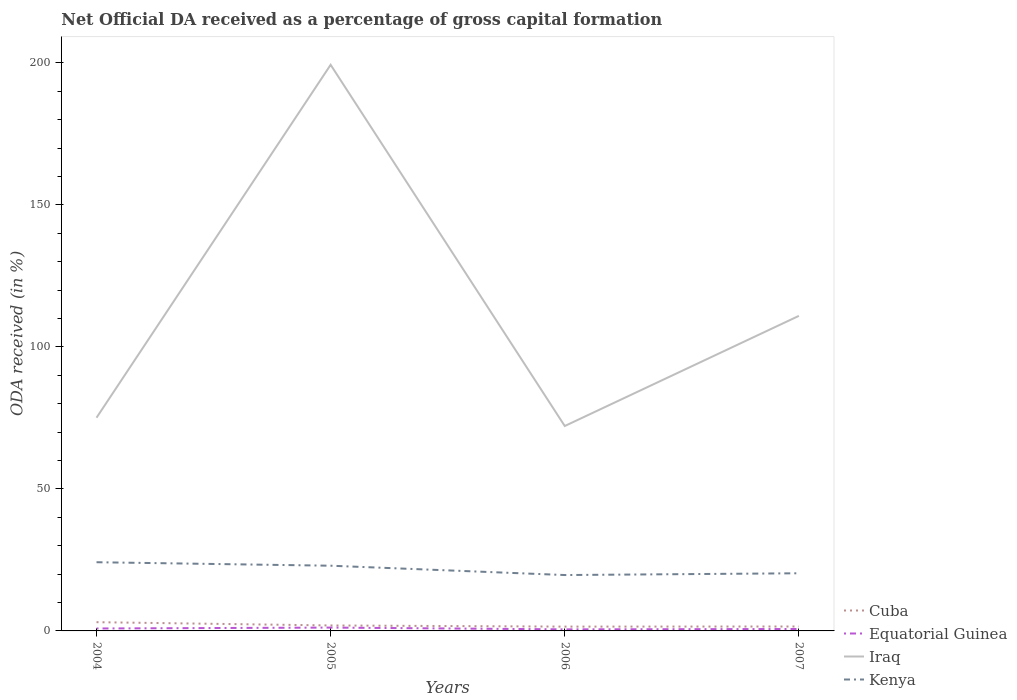How many different coloured lines are there?
Keep it short and to the point. 4. Does the line corresponding to Cuba intersect with the line corresponding to Equatorial Guinea?
Your response must be concise. No. Across all years, what is the maximum net ODA received in Cuba?
Make the answer very short. 1.51. What is the total net ODA received in Kenya in the graph?
Give a very brief answer. 3.28. What is the difference between the highest and the second highest net ODA received in Iraq?
Your answer should be very brief. 127.16. What is the difference between the highest and the lowest net ODA received in Cuba?
Provide a short and direct response. 1. Is the net ODA received in Kenya strictly greater than the net ODA received in Cuba over the years?
Offer a very short reply. No. What is the difference between two consecutive major ticks on the Y-axis?
Your response must be concise. 50. Are the values on the major ticks of Y-axis written in scientific E-notation?
Give a very brief answer. No. Does the graph contain any zero values?
Your response must be concise. No. Does the graph contain grids?
Your answer should be very brief. No. How many legend labels are there?
Provide a short and direct response. 4. How are the legend labels stacked?
Your answer should be very brief. Vertical. What is the title of the graph?
Provide a short and direct response. Net Official DA received as a percentage of gross capital formation. Does "Paraguay" appear as one of the legend labels in the graph?
Keep it short and to the point. No. What is the label or title of the Y-axis?
Offer a very short reply. ODA received (in %). What is the ODA received (in %) of Cuba in 2004?
Your response must be concise. 3.08. What is the ODA received (in %) of Equatorial Guinea in 2004?
Your answer should be compact. 0.86. What is the ODA received (in %) of Iraq in 2004?
Provide a succinct answer. 75.06. What is the ODA received (in %) of Kenya in 2004?
Provide a succinct answer. 24.18. What is the ODA received (in %) in Cuba in 2005?
Offer a very short reply. 1.92. What is the ODA received (in %) in Equatorial Guinea in 2005?
Your answer should be very brief. 1.18. What is the ODA received (in %) of Iraq in 2005?
Your answer should be very brief. 199.29. What is the ODA received (in %) of Kenya in 2005?
Provide a succinct answer. 22.96. What is the ODA received (in %) in Cuba in 2006?
Offer a very short reply. 1.51. What is the ODA received (in %) in Equatorial Guinea in 2006?
Provide a succinct answer. 0.55. What is the ODA received (in %) in Iraq in 2006?
Your answer should be compact. 72.14. What is the ODA received (in %) in Kenya in 2006?
Your answer should be very brief. 19.67. What is the ODA received (in %) of Cuba in 2007?
Keep it short and to the point. 1.55. What is the ODA received (in %) of Equatorial Guinea in 2007?
Keep it short and to the point. 0.68. What is the ODA received (in %) in Iraq in 2007?
Offer a very short reply. 110.91. What is the ODA received (in %) in Kenya in 2007?
Offer a terse response. 20.29. Across all years, what is the maximum ODA received (in %) of Cuba?
Your answer should be compact. 3.08. Across all years, what is the maximum ODA received (in %) in Equatorial Guinea?
Make the answer very short. 1.18. Across all years, what is the maximum ODA received (in %) of Iraq?
Your answer should be compact. 199.29. Across all years, what is the maximum ODA received (in %) in Kenya?
Make the answer very short. 24.18. Across all years, what is the minimum ODA received (in %) in Cuba?
Offer a very short reply. 1.51. Across all years, what is the minimum ODA received (in %) of Equatorial Guinea?
Provide a succinct answer. 0.55. Across all years, what is the minimum ODA received (in %) of Iraq?
Your answer should be very brief. 72.14. Across all years, what is the minimum ODA received (in %) of Kenya?
Provide a succinct answer. 19.67. What is the total ODA received (in %) of Cuba in the graph?
Your answer should be compact. 8.07. What is the total ODA received (in %) in Equatorial Guinea in the graph?
Provide a short and direct response. 3.26. What is the total ODA received (in %) of Iraq in the graph?
Keep it short and to the point. 457.39. What is the total ODA received (in %) of Kenya in the graph?
Your answer should be compact. 87.11. What is the difference between the ODA received (in %) of Cuba in 2004 and that in 2005?
Keep it short and to the point. 1.16. What is the difference between the ODA received (in %) in Equatorial Guinea in 2004 and that in 2005?
Offer a terse response. -0.32. What is the difference between the ODA received (in %) of Iraq in 2004 and that in 2005?
Give a very brief answer. -124.24. What is the difference between the ODA received (in %) of Kenya in 2004 and that in 2005?
Provide a succinct answer. 1.23. What is the difference between the ODA received (in %) in Cuba in 2004 and that in 2006?
Ensure brevity in your answer.  1.56. What is the difference between the ODA received (in %) of Equatorial Guinea in 2004 and that in 2006?
Give a very brief answer. 0.31. What is the difference between the ODA received (in %) of Iraq in 2004 and that in 2006?
Offer a terse response. 2.92. What is the difference between the ODA received (in %) of Kenya in 2004 and that in 2006?
Ensure brevity in your answer.  4.51. What is the difference between the ODA received (in %) in Cuba in 2004 and that in 2007?
Make the answer very short. 1.52. What is the difference between the ODA received (in %) in Equatorial Guinea in 2004 and that in 2007?
Provide a short and direct response. 0.18. What is the difference between the ODA received (in %) in Iraq in 2004 and that in 2007?
Keep it short and to the point. -35.85. What is the difference between the ODA received (in %) in Kenya in 2004 and that in 2007?
Ensure brevity in your answer.  3.89. What is the difference between the ODA received (in %) of Cuba in 2005 and that in 2006?
Offer a terse response. 0.41. What is the difference between the ODA received (in %) in Equatorial Guinea in 2005 and that in 2006?
Provide a succinct answer. 0.62. What is the difference between the ODA received (in %) in Iraq in 2005 and that in 2006?
Make the answer very short. 127.16. What is the difference between the ODA received (in %) of Kenya in 2005 and that in 2006?
Keep it short and to the point. 3.28. What is the difference between the ODA received (in %) in Cuba in 2005 and that in 2007?
Your response must be concise. 0.37. What is the difference between the ODA received (in %) of Equatorial Guinea in 2005 and that in 2007?
Your response must be concise. 0.5. What is the difference between the ODA received (in %) in Iraq in 2005 and that in 2007?
Ensure brevity in your answer.  88.39. What is the difference between the ODA received (in %) of Kenya in 2005 and that in 2007?
Offer a terse response. 2.66. What is the difference between the ODA received (in %) in Cuba in 2006 and that in 2007?
Provide a succinct answer. -0.04. What is the difference between the ODA received (in %) in Equatorial Guinea in 2006 and that in 2007?
Make the answer very short. -0.13. What is the difference between the ODA received (in %) in Iraq in 2006 and that in 2007?
Give a very brief answer. -38.77. What is the difference between the ODA received (in %) in Kenya in 2006 and that in 2007?
Make the answer very short. -0.62. What is the difference between the ODA received (in %) of Cuba in 2004 and the ODA received (in %) of Equatorial Guinea in 2005?
Provide a succinct answer. 1.9. What is the difference between the ODA received (in %) of Cuba in 2004 and the ODA received (in %) of Iraq in 2005?
Ensure brevity in your answer.  -196.21. What is the difference between the ODA received (in %) of Cuba in 2004 and the ODA received (in %) of Kenya in 2005?
Your answer should be very brief. -19.88. What is the difference between the ODA received (in %) in Equatorial Guinea in 2004 and the ODA received (in %) in Iraq in 2005?
Give a very brief answer. -198.44. What is the difference between the ODA received (in %) in Equatorial Guinea in 2004 and the ODA received (in %) in Kenya in 2005?
Provide a succinct answer. -22.1. What is the difference between the ODA received (in %) of Iraq in 2004 and the ODA received (in %) of Kenya in 2005?
Your answer should be compact. 52.1. What is the difference between the ODA received (in %) in Cuba in 2004 and the ODA received (in %) in Equatorial Guinea in 2006?
Your response must be concise. 2.53. What is the difference between the ODA received (in %) in Cuba in 2004 and the ODA received (in %) in Iraq in 2006?
Your answer should be compact. -69.06. What is the difference between the ODA received (in %) in Cuba in 2004 and the ODA received (in %) in Kenya in 2006?
Ensure brevity in your answer.  -16.59. What is the difference between the ODA received (in %) in Equatorial Guinea in 2004 and the ODA received (in %) in Iraq in 2006?
Offer a terse response. -71.28. What is the difference between the ODA received (in %) of Equatorial Guinea in 2004 and the ODA received (in %) of Kenya in 2006?
Ensure brevity in your answer.  -18.81. What is the difference between the ODA received (in %) of Iraq in 2004 and the ODA received (in %) of Kenya in 2006?
Give a very brief answer. 55.38. What is the difference between the ODA received (in %) in Cuba in 2004 and the ODA received (in %) in Equatorial Guinea in 2007?
Provide a succinct answer. 2.4. What is the difference between the ODA received (in %) in Cuba in 2004 and the ODA received (in %) in Iraq in 2007?
Your answer should be compact. -107.83. What is the difference between the ODA received (in %) of Cuba in 2004 and the ODA received (in %) of Kenya in 2007?
Keep it short and to the point. -17.22. What is the difference between the ODA received (in %) of Equatorial Guinea in 2004 and the ODA received (in %) of Iraq in 2007?
Make the answer very short. -110.05. What is the difference between the ODA received (in %) in Equatorial Guinea in 2004 and the ODA received (in %) in Kenya in 2007?
Offer a very short reply. -19.44. What is the difference between the ODA received (in %) of Iraq in 2004 and the ODA received (in %) of Kenya in 2007?
Keep it short and to the point. 54.76. What is the difference between the ODA received (in %) in Cuba in 2005 and the ODA received (in %) in Equatorial Guinea in 2006?
Provide a succinct answer. 1.37. What is the difference between the ODA received (in %) of Cuba in 2005 and the ODA received (in %) of Iraq in 2006?
Ensure brevity in your answer.  -70.21. What is the difference between the ODA received (in %) in Cuba in 2005 and the ODA received (in %) in Kenya in 2006?
Your response must be concise. -17.75. What is the difference between the ODA received (in %) of Equatorial Guinea in 2005 and the ODA received (in %) of Iraq in 2006?
Provide a succinct answer. -70.96. What is the difference between the ODA received (in %) of Equatorial Guinea in 2005 and the ODA received (in %) of Kenya in 2006?
Offer a terse response. -18.5. What is the difference between the ODA received (in %) of Iraq in 2005 and the ODA received (in %) of Kenya in 2006?
Your response must be concise. 179.62. What is the difference between the ODA received (in %) in Cuba in 2005 and the ODA received (in %) in Equatorial Guinea in 2007?
Provide a short and direct response. 1.25. What is the difference between the ODA received (in %) in Cuba in 2005 and the ODA received (in %) in Iraq in 2007?
Make the answer very short. -108.98. What is the difference between the ODA received (in %) in Cuba in 2005 and the ODA received (in %) in Kenya in 2007?
Your response must be concise. -18.37. What is the difference between the ODA received (in %) of Equatorial Guinea in 2005 and the ODA received (in %) of Iraq in 2007?
Your answer should be compact. -109.73. What is the difference between the ODA received (in %) of Equatorial Guinea in 2005 and the ODA received (in %) of Kenya in 2007?
Offer a very short reply. -19.12. What is the difference between the ODA received (in %) in Iraq in 2005 and the ODA received (in %) in Kenya in 2007?
Give a very brief answer. 179. What is the difference between the ODA received (in %) in Cuba in 2006 and the ODA received (in %) in Equatorial Guinea in 2007?
Make the answer very short. 0.84. What is the difference between the ODA received (in %) in Cuba in 2006 and the ODA received (in %) in Iraq in 2007?
Your answer should be compact. -109.39. What is the difference between the ODA received (in %) in Cuba in 2006 and the ODA received (in %) in Kenya in 2007?
Ensure brevity in your answer.  -18.78. What is the difference between the ODA received (in %) in Equatorial Guinea in 2006 and the ODA received (in %) in Iraq in 2007?
Offer a terse response. -110.36. What is the difference between the ODA received (in %) of Equatorial Guinea in 2006 and the ODA received (in %) of Kenya in 2007?
Your answer should be very brief. -19.74. What is the difference between the ODA received (in %) of Iraq in 2006 and the ODA received (in %) of Kenya in 2007?
Your answer should be compact. 51.84. What is the average ODA received (in %) in Cuba per year?
Your answer should be very brief. 2.02. What is the average ODA received (in %) in Equatorial Guinea per year?
Provide a short and direct response. 0.82. What is the average ODA received (in %) of Iraq per year?
Give a very brief answer. 114.35. What is the average ODA received (in %) of Kenya per year?
Make the answer very short. 21.78. In the year 2004, what is the difference between the ODA received (in %) in Cuba and ODA received (in %) in Equatorial Guinea?
Keep it short and to the point. 2.22. In the year 2004, what is the difference between the ODA received (in %) of Cuba and ODA received (in %) of Iraq?
Ensure brevity in your answer.  -71.98. In the year 2004, what is the difference between the ODA received (in %) of Cuba and ODA received (in %) of Kenya?
Your answer should be very brief. -21.1. In the year 2004, what is the difference between the ODA received (in %) of Equatorial Guinea and ODA received (in %) of Iraq?
Offer a terse response. -74.2. In the year 2004, what is the difference between the ODA received (in %) of Equatorial Guinea and ODA received (in %) of Kenya?
Make the answer very short. -23.32. In the year 2004, what is the difference between the ODA received (in %) in Iraq and ODA received (in %) in Kenya?
Provide a succinct answer. 50.87. In the year 2005, what is the difference between the ODA received (in %) in Cuba and ODA received (in %) in Equatorial Guinea?
Make the answer very short. 0.75. In the year 2005, what is the difference between the ODA received (in %) of Cuba and ODA received (in %) of Iraq?
Your response must be concise. -197.37. In the year 2005, what is the difference between the ODA received (in %) of Cuba and ODA received (in %) of Kenya?
Offer a very short reply. -21.03. In the year 2005, what is the difference between the ODA received (in %) in Equatorial Guinea and ODA received (in %) in Iraq?
Offer a very short reply. -198.12. In the year 2005, what is the difference between the ODA received (in %) of Equatorial Guinea and ODA received (in %) of Kenya?
Ensure brevity in your answer.  -21.78. In the year 2005, what is the difference between the ODA received (in %) of Iraq and ODA received (in %) of Kenya?
Provide a succinct answer. 176.34. In the year 2006, what is the difference between the ODA received (in %) in Cuba and ODA received (in %) in Equatorial Guinea?
Offer a terse response. 0.96. In the year 2006, what is the difference between the ODA received (in %) in Cuba and ODA received (in %) in Iraq?
Ensure brevity in your answer.  -70.62. In the year 2006, what is the difference between the ODA received (in %) of Cuba and ODA received (in %) of Kenya?
Ensure brevity in your answer.  -18.16. In the year 2006, what is the difference between the ODA received (in %) of Equatorial Guinea and ODA received (in %) of Iraq?
Make the answer very short. -71.58. In the year 2006, what is the difference between the ODA received (in %) of Equatorial Guinea and ODA received (in %) of Kenya?
Offer a very short reply. -19.12. In the year 2006, what is the difference between the ODA received (in %) of Iraq and ODA received (in %) of Kenya?
Your answer should be very brief. 52.46. In the year 2007, what is the difference between the ODA received (in %) of Cuba and ODA received (in %) of Equatorial Guinea?
Provide a succinct answer. 0.88. In the year 2007, what is the difference between the ODA received (in %) of Cuba and ODA received (in %) of Iraq?
Offer a terse response. -109.35. In the year 2007, what is the difference between the ODA received (in %) in Cuba and ODA received (in %) in Kenya?
Ensure brevity in your answer.  -18.74. In the year 2007, what is the difference between the ODA received (in %) in Equatorial Guinea and ODA received (in %) in Iraq?
Give a very brief answer. -110.23. In the year 2007, what is the difference between the ODA received (in %) of Equatorial Guinea and ODA received (in %) of Kenya?
Your answer should be very brief. -19.62. In the year 2007, what is the difference between the ODA received (in %) of Iraq and ODA received (in %) of Kenya?
Offer a very short reply. 90.61. What is the ratio of the ODA received (in %) of Cuba in 2004 to that in 2005?
Offer a terse response. 1.6. What is the ratio of the ODA received (in %) in Equatorial Guinea in 2004 to that in 2005?
Offer a terse response. 0.73. What is the ratio of the ODA received (in %) of Iraq in 2004 to that in 2005?
Keep it short and to the point. 0.38. What is the ratio of the ODA received (in %) in Kenya in 2004 to that in 2005?
Keep it short and to the point. 1.05. What is the ratio of the ODA received (in %) of Cuba in 2004 to that in 2006?
Ensure brevity in your answer.  2.03. What is the ratio of the ODA received (in %) of Equatorial Guinea in 2004 to that in 2006?
Your response must be concise. 1.56. What is the ratio of the ODA received (in %) of Iraq in 2004 to that in 2006?
Ensure brevity in your answer.  1.04. What is the ratio of the ODA received (in %) in Kenya in 2004 to that in 2006?
Ensure brevity in your answer.  1.23. What is the ratio of the ODA received (in %) of Cuba in 2004 to that in 2007?
Make the answer very short. 1.98. What is the ratio of the ODA received (in %) of Equatorial Guinea in 2004 to that in 2007?
Provide a short and direct response. 1.27. What is the ratio of the ODA received (in %) of Iraq in 2004 to that in 2007?
Keep it short and to the point. 0.68. What is the ratio of the ODA received (in %) of Kenya in 2004 to that in 2007?
Your answer should be very brief. 1.19. What is the ratio of the ODA received (in %) of Cuba in 2005 to that in 2006?
Provide a succinct answer. 1.27. What is the ratio of the ODA received (in %) in Equatorial Guinea in 2005 to that in 2006?
Your response must be concise. 2.13. What is the ratio of the ODA received (in %) of Iraq in 2005 to that in 2006?
Offer a terse response. 2.76. What is the ratio of the ODA received (in %) of Kenya in 2005 to that in 2006?
Keep it short and to the point. 1.17. What is the ratio of the ODA received (in %) in Cuba in 2005 to that in 2007?
Provide a short and direct response. 1.24. What is the ratio of the ODA received (in %) in Equatorial Guinea in 2005 to that in 2007?
Your answer should be compact. 1.74. What is the ratio of the ODA received (in %) in Iraq in 2005 to that in 2007?
Your response must be concise. 1.8. What is the ratio of the ODA received (in %) of Kenya in 2005 to that in 2007?
Make the answer very short. 1.13. What is the ratio of the ODA received (in %) of Cuba in 2006 to that in 2007?
Offer a very short reply. 0.97. What is the ratio of the ODA received (in %) of Equatorial Guinea in 2006 to that in 2007?
Your response must be concise. 0.81. What is the ratio of the ODA received (in %) in Iraq in 2006 to that in 2007?
Provide a short and direct response. 0.65. What is the ratio of the ODA received (in %) of Kenya in 2006 to that in 2007?
Ensure brevity in your answer.  0.97. What is the difference between the highest and the second highest ODA received (in %) of Cuba?
Keep it short and to the point. 1.16. What is the difference between the highest and the second highest ODA received (in %) of Equatorial Guinea?
Your answer should be very brief. 0.32. What is the difference between the highest and the second highest ODA received (in %) of Iraq?
Make the answer very short. 88.39. What is the difference between the highest and the second highest ODA received (in %) in Kenya?
Keep it short and to the point. 1.23. What is the difference between the highest and the lowest ODA received (in %) of Cuba?
Offer a terse response. 1.56. What is the difference between the highest and the lowest ODA received (in %) of Equatorial Guinea?
Provide a short and direct response. 0.62. What is the difference between the highest and the lowest ODA received (in %) in Iraq?
Provide a succinct answer. 127.16. What is the difference between the highest and the lowest ODA received (in %) of Kenya?
Offer a very short reply. 4.51. 